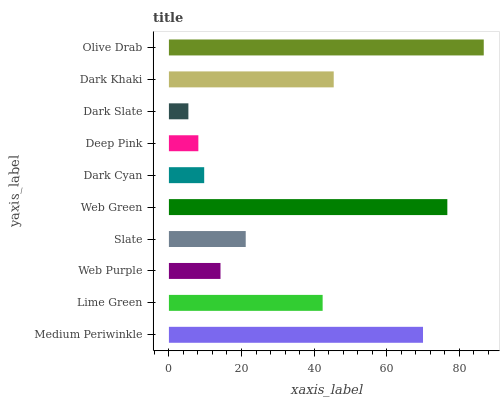Is Dark Slate the minimum?
Answer yes or no. Yes. Is Olive Drab the maximum?
Answer yes or no. Yes. Is Lime Green the minimum?
Answer yes or no. No. Is Lime Green the maximum?
Answer yes or no. No. Is Medium Periwinkle greater than Lime Green?
Answer yes or no. Yes. Is Lime Green less than Medium Periwinkle?
Answer yes or no. Yes. Is Lime Green greater than Medium Periwinkle?
Answer yes or no. No. Is Medium Periwinkle less than Lime Green?
Answer yes or no. No. Is Lime Green the high median?
Answer yes or no. Yes. Is Slate the low median?
Answer yes or no. Yes. Is Deep Pink the high median?
Answer yes or no. No. Is Medium Periwinkle the low median?
Answer yes or no. No. 